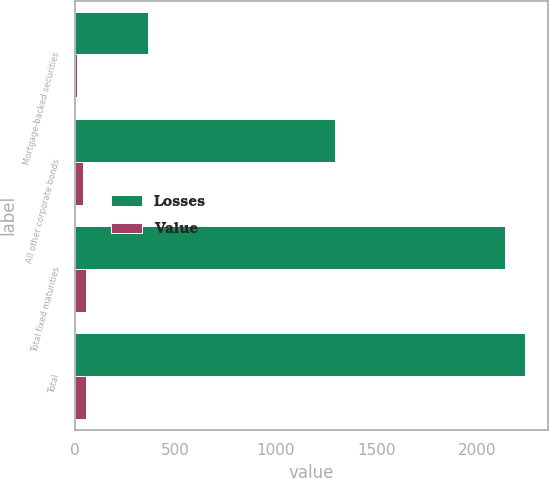<chart> <loc_0><loc_0><loc_500><loc_500><stacked_bar_chart><ecel><fcel>Mortgage-backed securities<fcel>All other corporate bonds<fcel>Total fixed maturities<fcel>Total<nl><fcel>Losses<fcel>362<fcel>1295<fcel>2136<fcel>2237<nl><fcel>Value<fcel>12<fcel>42<fcel>55<fcel>59<nl></chart> 